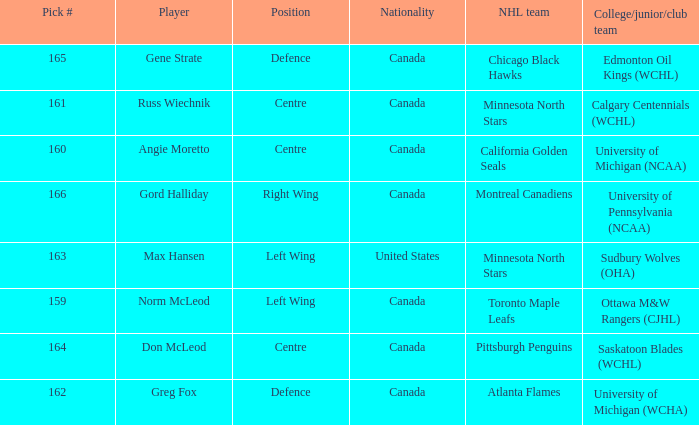What is the nationality of the player from the University of Michigan (NCAA)? Canada. 